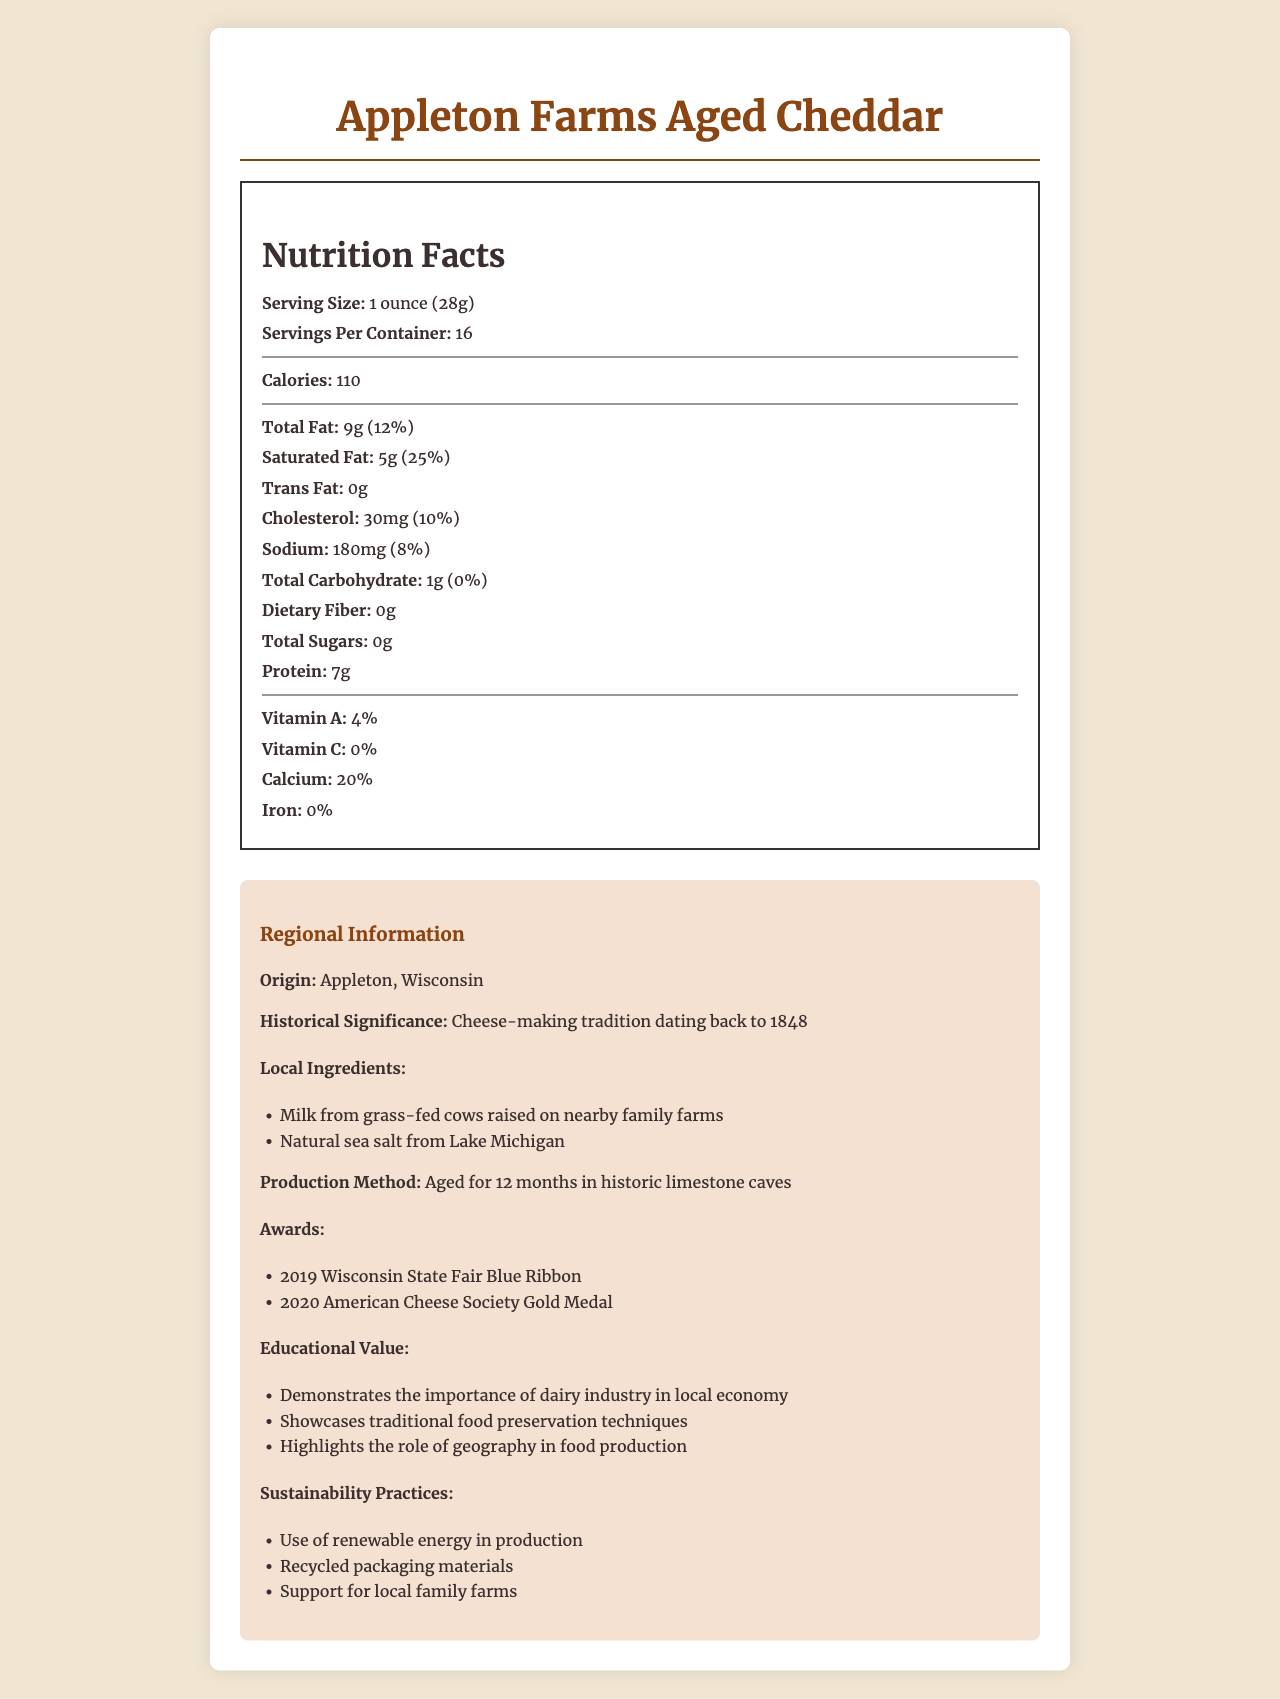What is the serving size for Appleton Farms Aged Cheddar? The document specifies that the serving size is 1 ounce, which is equivalent to 28 grams.
Answer: 1 ounce (28g) How many servings are there per container? The document states that there are 16 servings per container.
Answer: 16 How many calories are in a serving of Appleton Farms Aged Cheddar? According to the document, each serving contains 110 calories.
Answer: 110 What is the total fat content in a serving, and what percentage of the daily value does it represent? The total fat content per serving is 9 grams, which represents 12% of the daily value.
Answer: 9g (12%) How much protein does each serving contain? The document indicates that each serving contains 7 grams of protein.
Answer: 7g What is the historical significance of Appleton Farms Aged Cheddar? The document mentions that the cheese-making tradition for this product dates back to 1848.
Answer: Cheese-making tradition dating back to 1848 Which local ingredient is used in Appleton Farms Aged Cheddar? A. Organic tomatoes B. Grass-fed cow milk C. Seaweed from the Pacific Ocean The document lists "Milk from grass-fed cows raised on nearby family farms" as a local ingredient.
Answer: B. Grass-fed cow milk What percentage of the daily value of calcium does one serving of this cheese provide? A. 10% B. 15% C. 20% D. 25% The document specifies that one serving provides 20% of the daily value of calcium.
Answer: C. 20% Does the Appleton Farms Aged Cheddar contain any dietary fiber? The document specifies that there is 0 grams of dietary fiber in the cheese.
Answer: No Is the Appleton Farms Aged Cheddar aged for more than a year? The document states that the cheese is aged for 12 months, which is exactly one year.
Answer: Yes Summarize the main ideas presented in the document regarding Appleton Farms Aged Cheddar. The document provides detailed nutritional information, the historical background of the product, local ingredients, the production method, awards received, educational value, and sustainability practices related to Appleton Farms Aged Cheddar.
Answer: Appleton Farms Aged Cheddar is a locally-produced artisanal aged cheddar from Appleton, Wisconsin with a cheese-making tradition dating back to 1848. Each serving size is 1 ounce (28 grams), and there are 16 servings per container. The cheese is rich in protein and calcium but contains no dietary fiber or sugars. Aged for 12 months in historic limestone caves, it uses local ingredients like milk from grass-fed cows and natural sea salt. The product has won several awards, highlights traditional food preservation techniques, and embraces sustainability practices such as using renewable energy and supporting local family farms. What is the main sustainability practice related to the production of Appleton Farms Aged Cheddar? The document lists "Use of renewable energy in production" as a key sustainability practice.
Answer: Use of renewable energy in production What year did Appleton Farms Aged Cheddar win the Wisconsin State Fair Blue Ribbon? The document states that the cheese won the Wisconsin State Fair Blue Ribbon in 2019.
Answer: 2019 What type of food preservation technique is showcased by Appleton Farms Aged Cheddar's production? The document mentions that the cheese is aged for 12 months in historic limestone caves, showcasing traditional food preservation techniques.
Answer: Aged for 12 months in historic limestone caves How much trans fat does each serving of Appleton Farms Aged Cheddar contain? According to the document, each serving contains 0 grams of trans fat.
Answer: 0g Can you determine the lactose content in the cheese based on the document? The document does not provide any specific information about the lactose content in the cheese.
Answer: Cannot be determined 